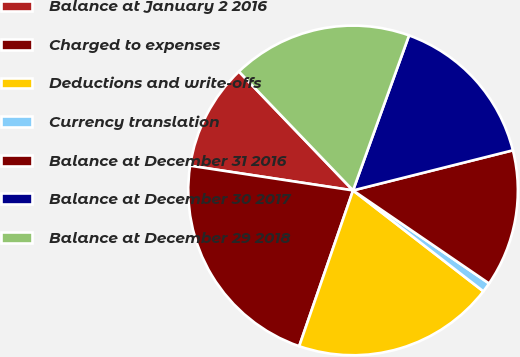Convert chart to OTSL. <chart><loc_0><loc_0><loc_500><loc_500><pie_chart><fcel>Balance at January 2 2016<fcel>Charged to expenses<fcel>Deductions and write-offs<fcel>Currency translation<fcel>Balance at December 31 2016<fcel>Balance at December 30 2017<fcel>Balance at December 29 2018<nl><fcel>10.43%<fcel>22.1%<fcel>19.81%<fcel>0.94%<fcel>13.46%<fcel>15.57%<fcel>17.69%<nl></chart> 